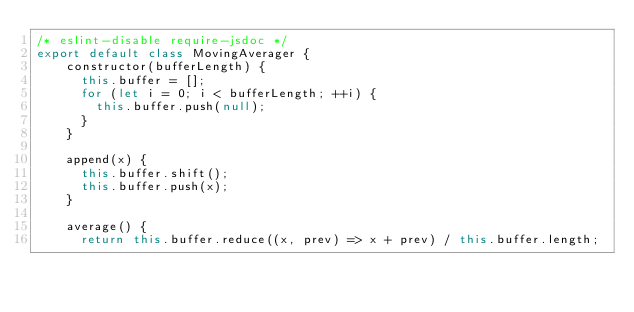Convert code to text. <code><loc_0><loc_0><loc_500><loc_500><_JavaScript_>/* eslint-disable require-jsdoc */
export default class MovingAverager {
    constructor(bufferLength) {
      this.buffer = [];
      for (let i = 0; i < bufferLength; ++i) {
        this.buffer.push(null);
      }
    }
  
    append(x) {
      this.buffer.shift();
      this.buffer.push(x);
    }
  
    average() {
      return this.buffer.reduce((x, prev) => x + prev) / this.buffer.length;</code> 